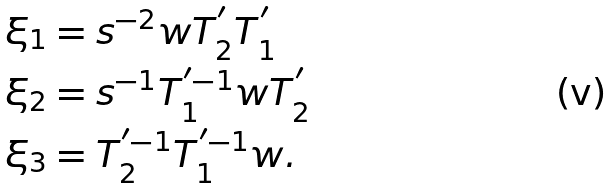<formula> <loc_0><loc_0><loc_500><loc_500>\xi _ { 1 } & = s ^ { - 2 } w T _ { 2 } ^ { ^ { \prime } } T _ { 1 } ^ { ^ { \prime } } \\ \xi _ { 2 } & = s ^ { - 1 } T _ { 1 } ^ { ^ { \prime } - 1 } w T _ { 2 } ^ { ^ { \prime } } \\ \xi _ { 3 } & = T _ { 2 } ^ { ^ { \prime } - 1 } T _ { 1 } ^ { ^ { \prime } - 1 } w .</formula> 